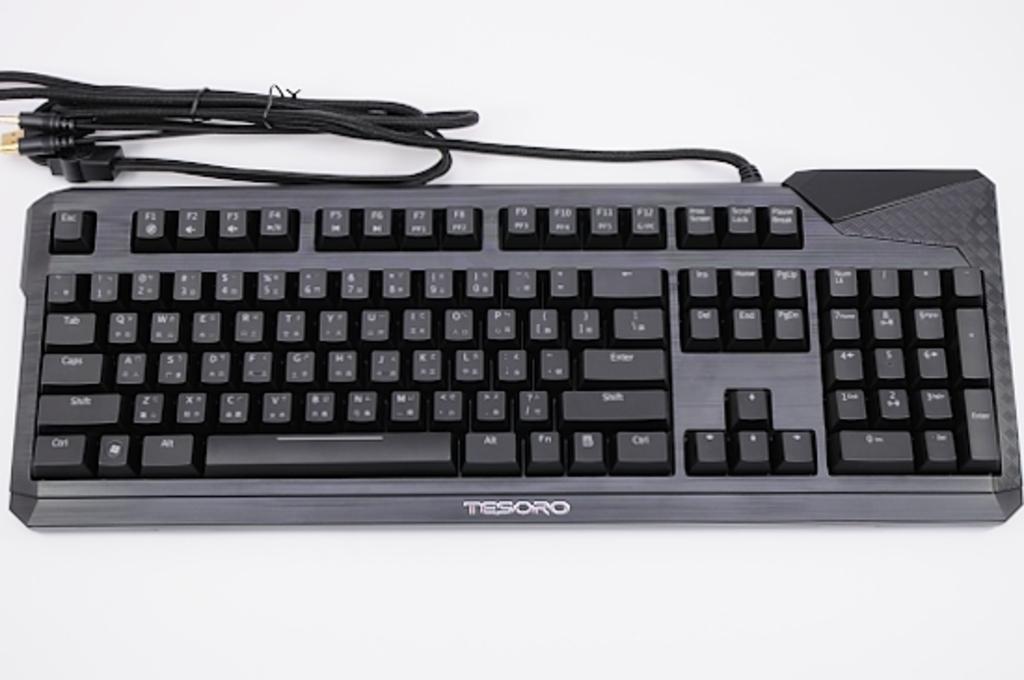Please provide a concise description of this image. In the center of the image we can see a keyboard placed on the table. 